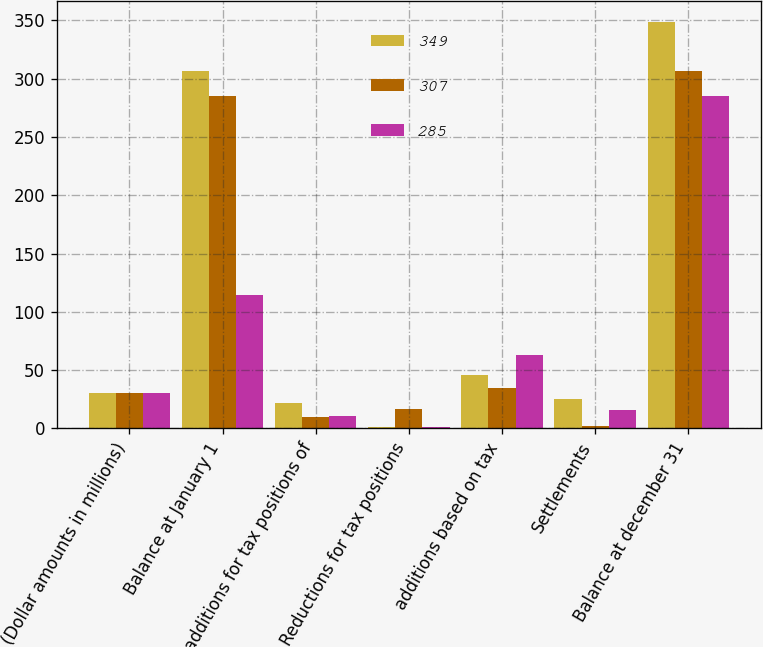Convert chart. <chart><loc_0><loc_0><loc_500><loc_500><stacked_bar_chart><ecel><fcel>(Dollar amounts in millions)<fcel>Balance at January 1<fcel>additions for tax positions of<fcel>Reductions for tax positions<fcel>additions based on tax<fcel>Settlements<fcel>Balance at december 31<nl><fcel>349<fcel>30<fcel>307<fcel>22<fcel>1<fcel>46<fcel>25<fcel>349<nl><fcel>307<fcel>30<fcel>285<fcel>10<fcel>17<fcel>35<fcel>2<fcel>307<nl><fcel>285<fcel>30<fcel>114<fcel>11<fcel>1<fcel>63<fcel>16<fcel>285<nl></chart> 